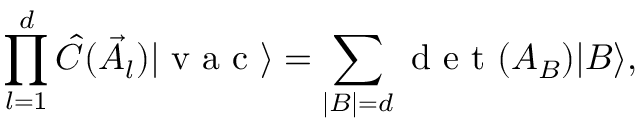<formula> <loc_0><loc_0><loc_500><loc_500>\prod _ { l = 1 } ^ { d } \hat { C } ( \vec { A } _ { l } ) | v a c \rangle = \sum _ { | B | = d } d e t ( A _ { B } ) | B \rangle ,</formula> 